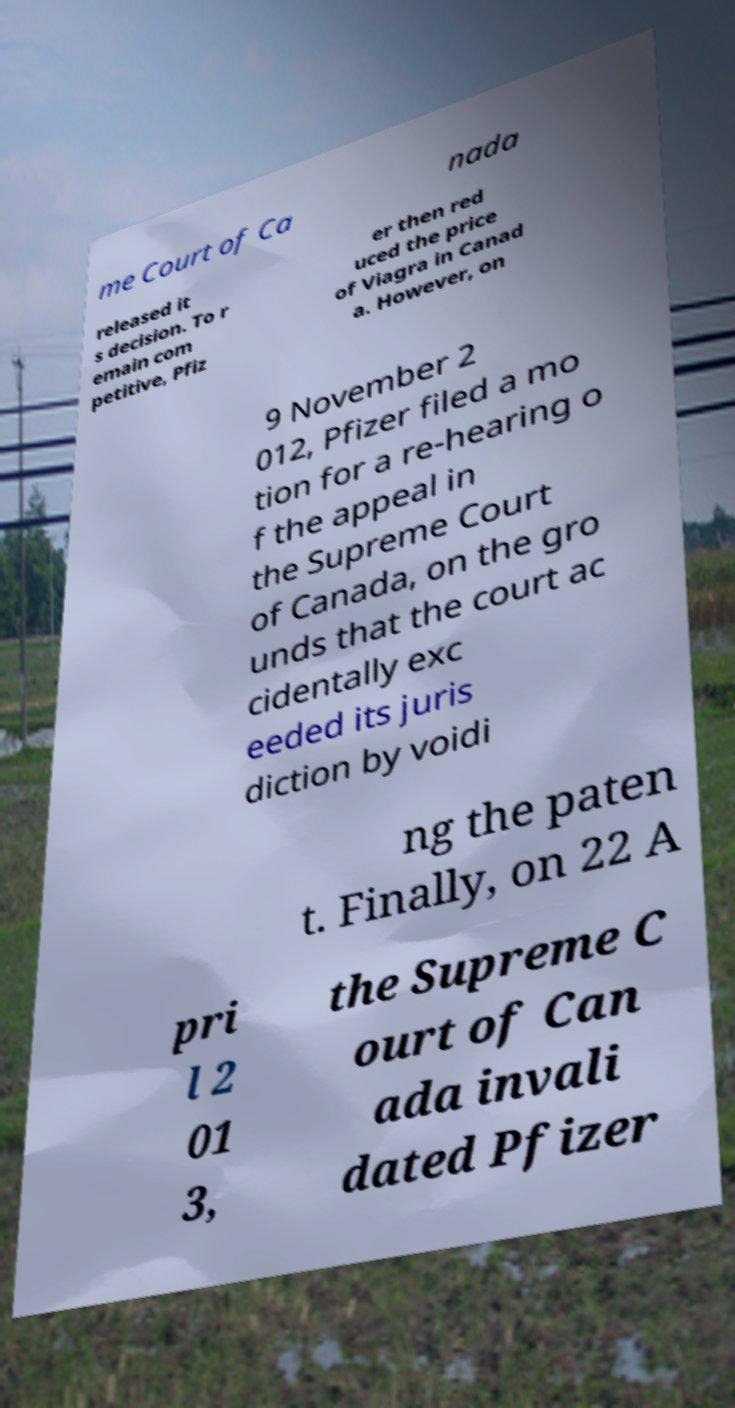Can you accurately transcribe the text from the provided image for me? me Court of Ca nada released it s decision. To r emain com petitive, Pfiz er then red uced the price of Viagra in Canad a. However, on 9 November 2 012, Pfizer filed a mo tion for a re-hearing o f the appeal in the Supreme Court of Canada, on the gro unds that the court ac cidentally exc eeded its juris diction by voidi ng the paten t. Finally, on 22 A pri l 2 01 3, the Supreme C ourt of Can ada invali dated Pfizer 